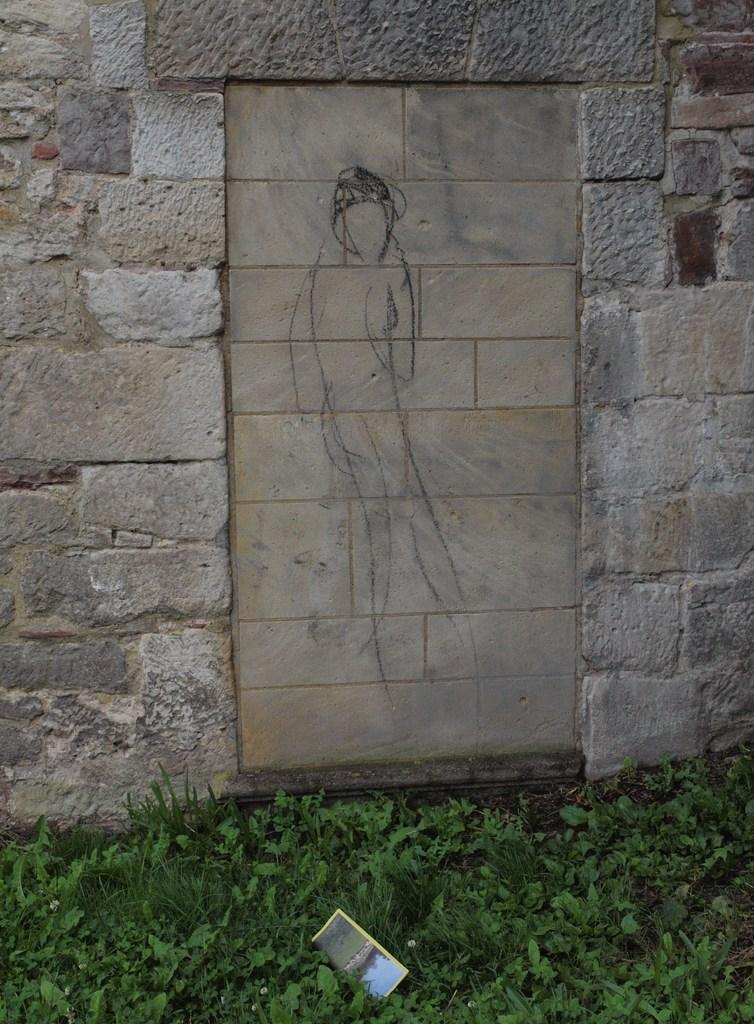What type of wall is shown in the image? There is a wall built with stones in the image. What can be seen on the wall? There are drawings on the wall. What is on the ground in the image? There is a paper on the ground in the image. What type of vegetation is visible in the image? There are plants and grass visible in the image. How do the children sort the different colors of the playground in the image? There is no playground present in the image, so the question cannot be answered. 